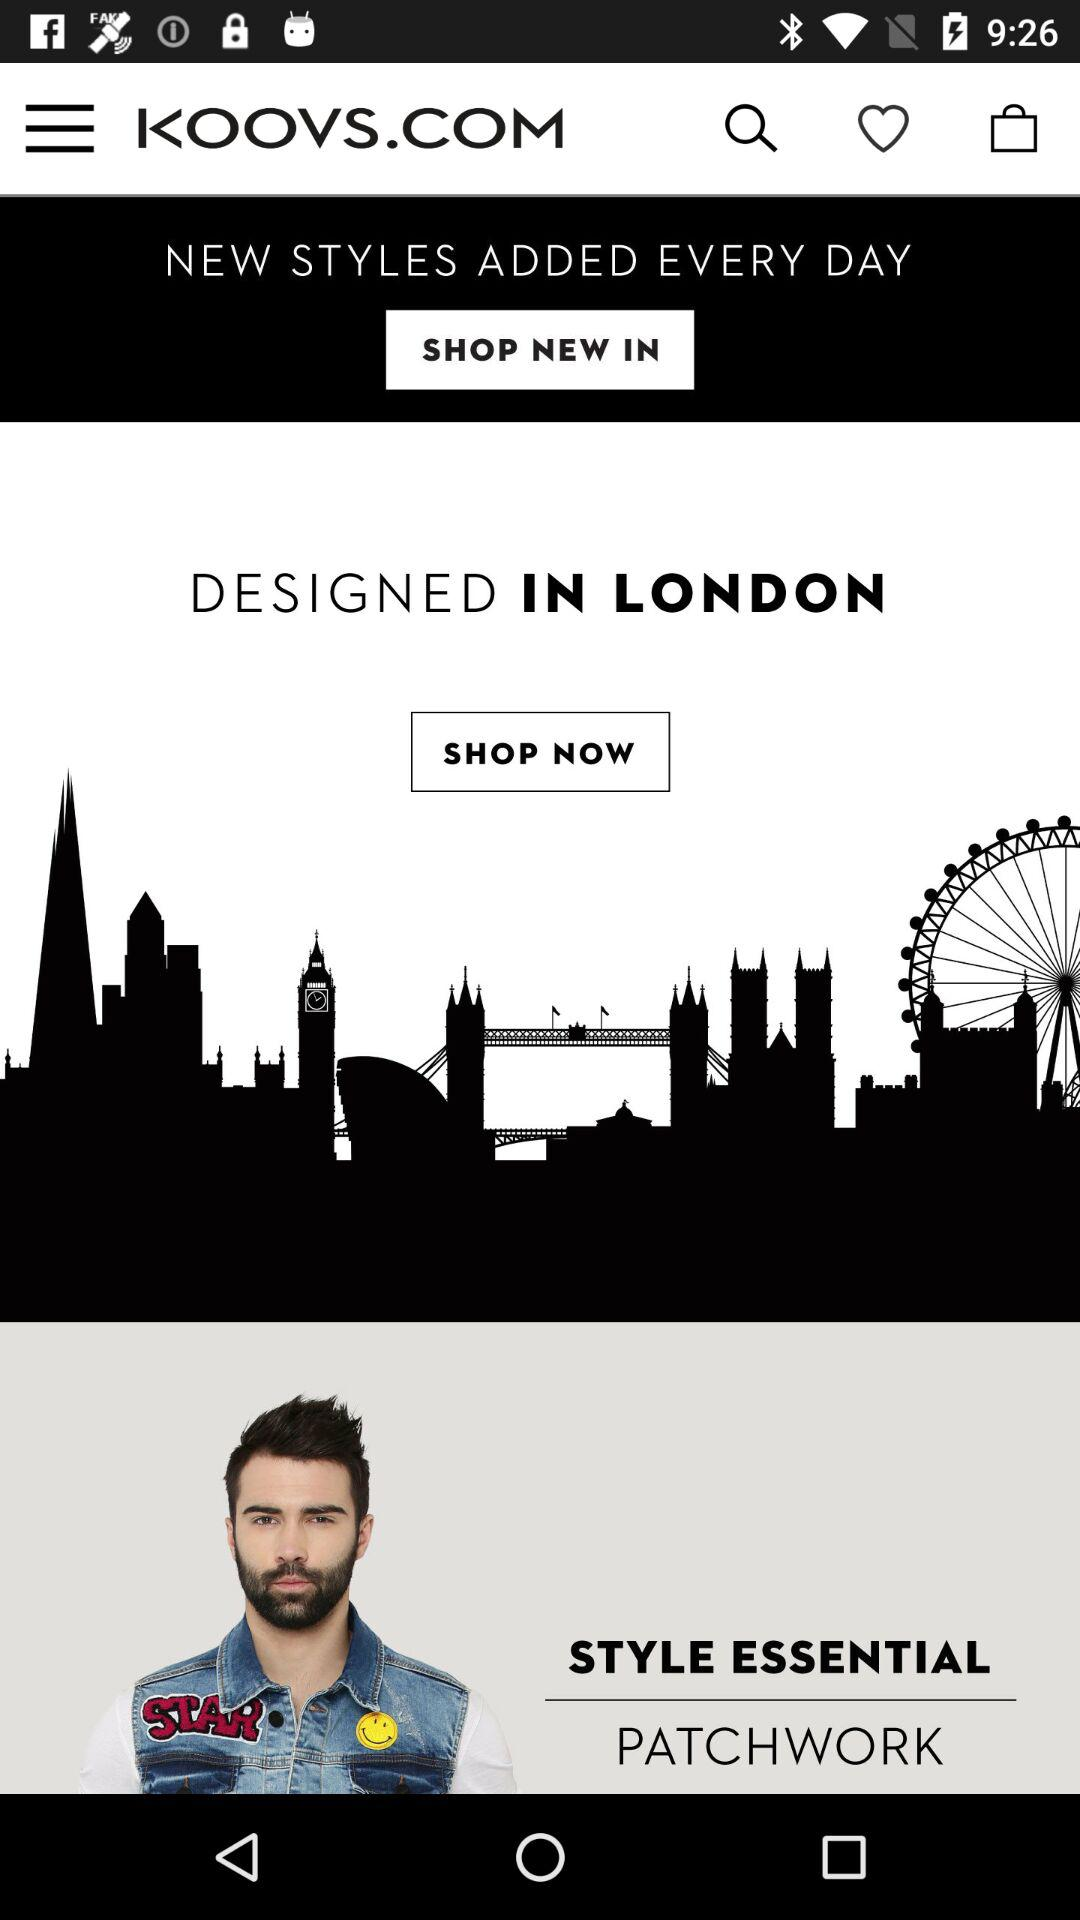What is added every day? Every day, new styles are added. 